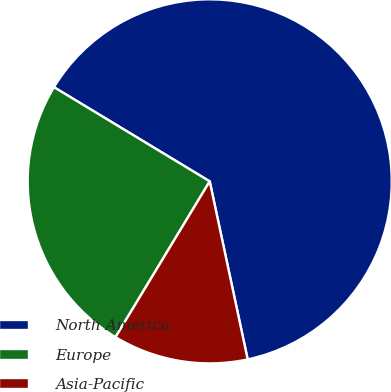Convert chart. <chart><loc_0><loc_0><loc_500><loc_500><pie_chart><fcel>North America<fcel>Europe<fcel>Asia-Pacific<nl><fcel>63.0%<fcel>25.0%<fcel>12.0%<nl></chart> 